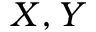<formula> <loc_0><loc_0><loc_500><loc_500>X , Y</formula> 